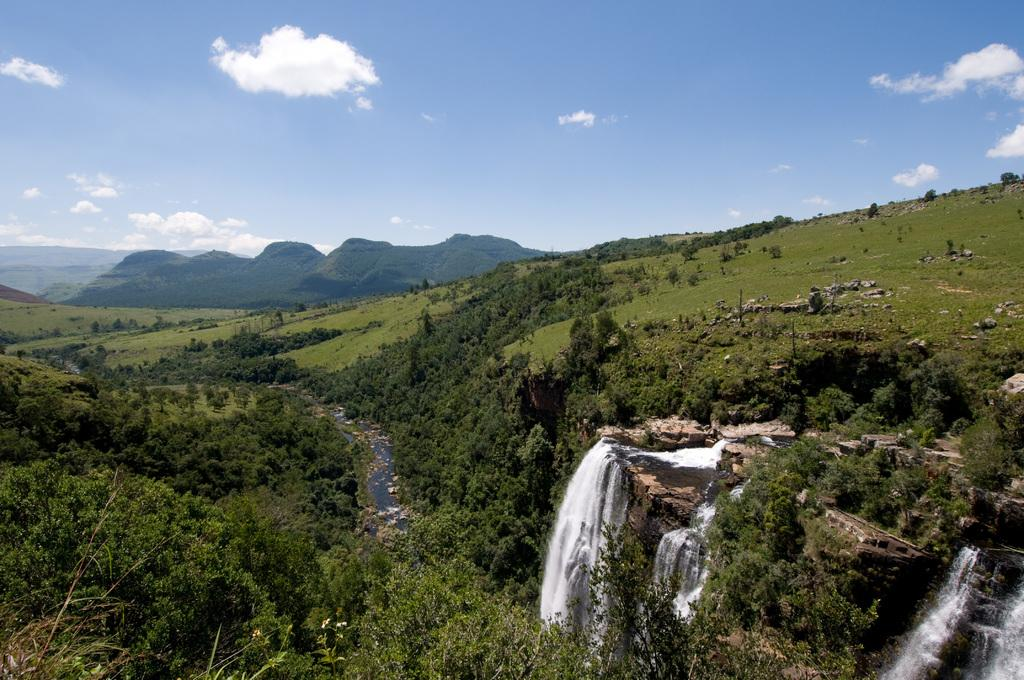What type of natural landforms can be seen in the image? There are hills in the image. What other natural elements are present in the image? There are trees, waterfalls, and rocks in the image. What is visible in the sky at the top of the image? There are clouds in the sky at the top of the image. Can you see a crown on top of the waterfall in the image? There is no crown present in the image; it features natural elements such as hills, trees, waterfalls, and rocks. Are there any balls visible in the image? There are no balls present in the image. 